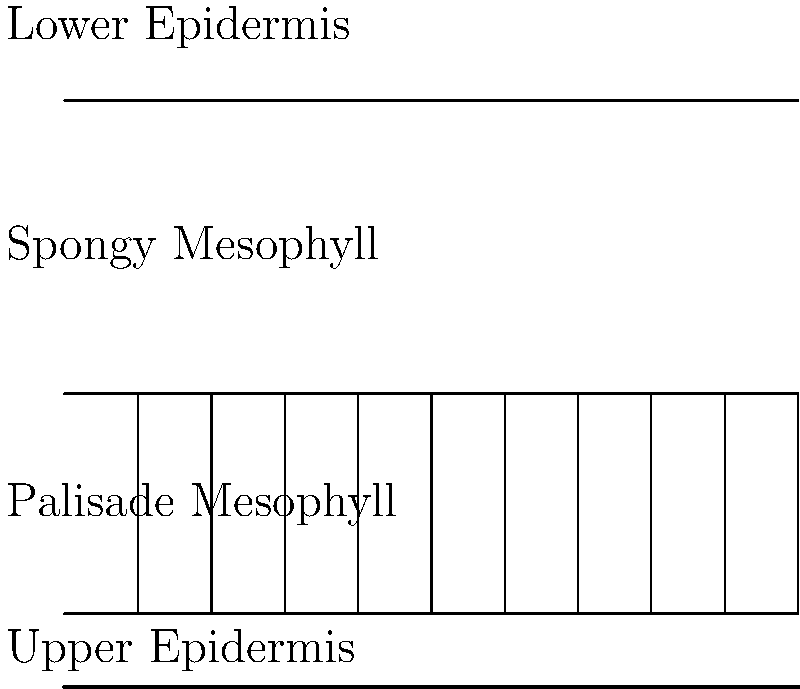Analyze the microscopic cross-section diagram of a plant leaf. Which layer is primarily responsible for the majority of photosynthesis, and what unique structural feature does it possess to maximize this function? To answer this question, let's examine the leaf structure layer by layer:

1. The outermost layers are the upper and lower epidermis, which primarily serve as protective layers.

2. Below the upper epidermis is the palisade mesophyll layer. This layer is characterized by tightly packed, column-like cells.

3. The spongy mesophyll layer is beneath the palisade layer, consisting of loosely arranged cells with large intercellular spaces.

4. The palisade mesophyll layer is primarily responsible for the majority of photosynthesis in the leaf. This is due to several factors:

   a) Its position directly beneath the upper epidermis allows it to receive the most sunlight.
   
   b) The cells in this layer are elongated and tightly packed, forming a column-like structure. This unique structural feature maximizes the surface area exposed to light.
   
   c) These cells contain a high concentration of chloroplasts, the organelles where photosynthesis occurs.

5. The column-like structure of the palisade cells allows for efficient light absorption and CO₂ diffusion, optimizing the photosynthetic process.

Therefore, the palisade mesophyll layer, with its unique column-like cellular structure, is primarily responsible for the majority of photosynthesis in the leaf.
Answer: Palisade mesophyll; column-like cellular structure 